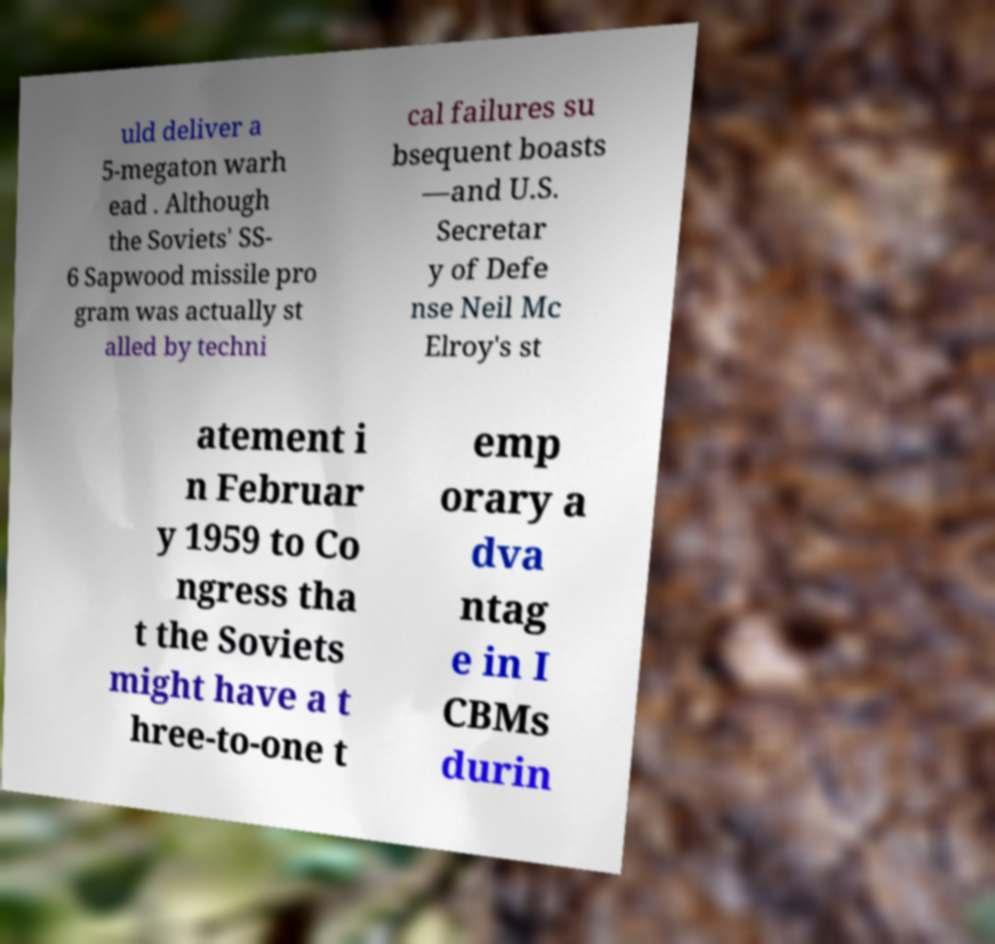Can you read and provide the text displayed in the image?This photo seems to have some interesting text. Can you extract and type it out for me? uld deliver a 5-megaton warh ead . Although the Soviets' SS- 6 Sapwood missile pro gram was actually st alled by techni cal failures su bsequent boasts —and U.S. Secretar y of Defe nse Neil Mc Elroy's st atement i n Februar y 1959 to Co ngress tha t the Soviets might have a t hree-to-one t emp orary a dva ntag e in I CBMs durin 